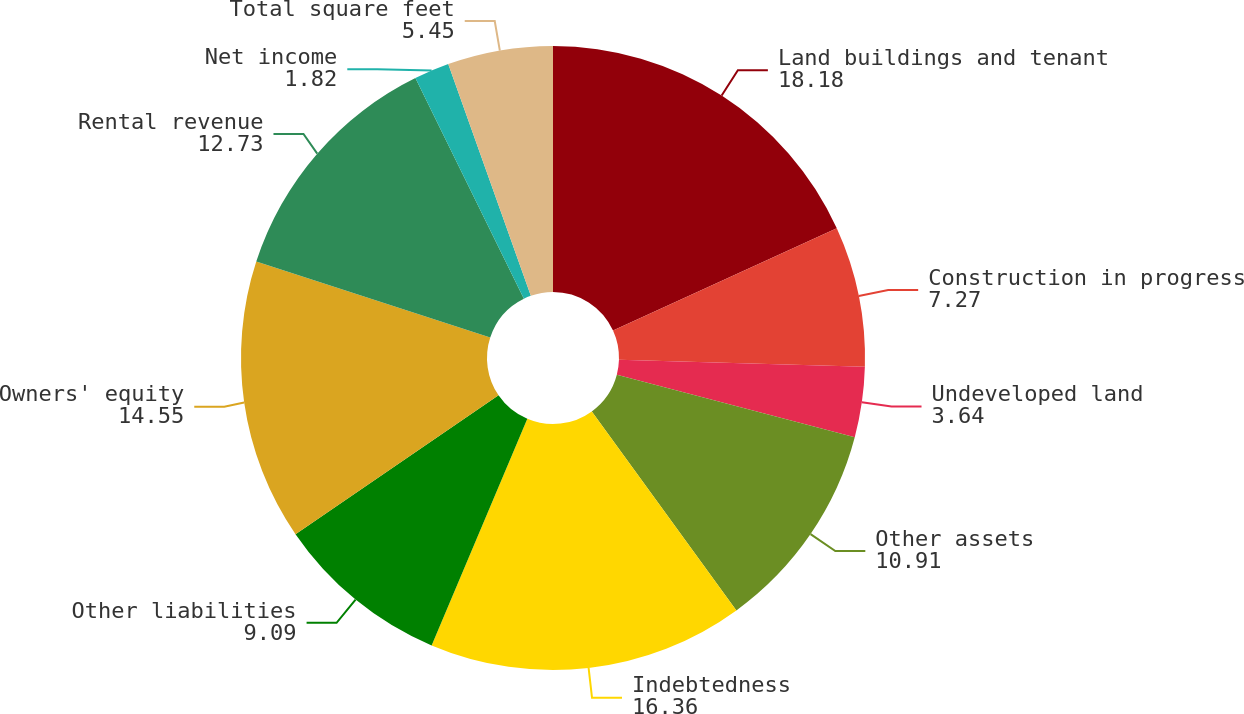Convert chart to OTSL. <chart><loc_0><loc_0><loc_500><loc_500><pie_chart><fcel>Land buildings and tenant<fcel>Construction in progress<fcel>Undeveloped land<fcel>Other assets<fcel>Indebtedness<fcel>Other liabilities<fcel>Owners' equity<fcel>Rental revenue<fcel>Net income<fcel>Total square feet<nl><fcel>18.18%<fcel>7.27%<fcel>3.64%<fcel>10.91%<fcel>16.36%<fcel>9.09%<fcel>14.55%<fcel>12.73%<fcel>1.82%<fcel>5.45%<nl></chart> 